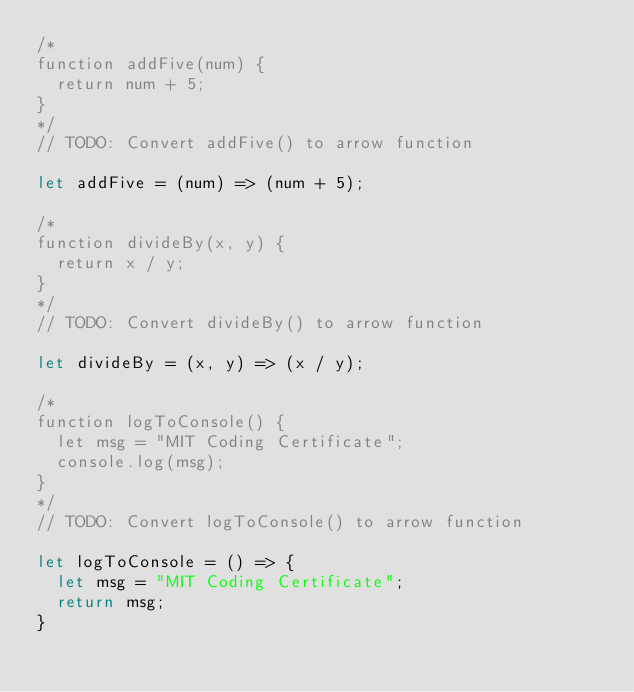<code> <loc_0><loc_0><loc_500><loc_500><_JavaScript_>/*
function addFive(num) {
  return num + 5;
}
*/
// TODO: Convert addFive() to arrow function

let addFive = (num) => (num + 5);

/*
function divideBy(x, y) {
  return x / y;
}
*/
// TODO: Convert divideBy() to arrow function

let divideBy = (x, y) => (x / y);

/*
function logToConsole() {
  let msg = "MIT Coding Certificate";
  console.log(msg);
}
*/
// TODO: Convert logToConsole() to arrow function

let logToConsole = () => {
  let msg = "MIT Coding Certificate";
  return msg;
}
</code> 